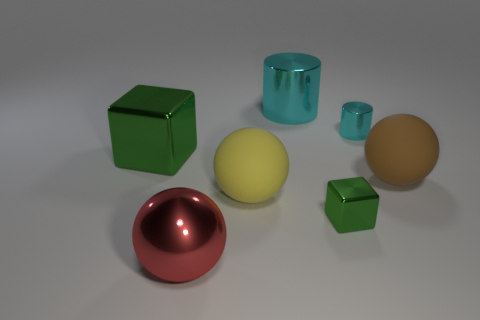Add 3 blocks. How many objects exist? 10 Subtract all cylinders. How many objects are left? 5 Add 1 small blocks. How many small blocks exist? 2 Subtract 0 yellow cylinders. How many objects are left? 7 Subtract all large cubes. Subtract all tiny green blocks. How many objects are left? 5 Add 4 yellow objects. How many yellow objects are left? 5 